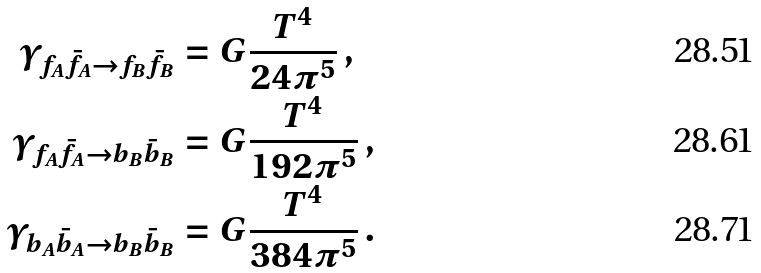Convert formula to latex. <formula><loc_0><loc_0><loc_500><loc_500>\gamma _ { f _ { A } \bar { f } _ { A } \to f _ { B } \bar { f } _ { B } } & = G \frac { T ^ { 4 } } { 2 4 \pi ^ { 5 } } \, , \\ \gamma _ { f _ { A } \bar { f } _ { A } \to b _ { B } \bar { b } _ { B } } & = G \frac { T ^ { 4 } } { 1 9 2 \pi ^ { 5 } } \, , \\ \gamma _ { b _ { A } \bar { b } _ { A } \to b _ { B } \bar { b } _ { B } } & = G \frac { T ^ { 4 } } { 3 8 4 \pi ^ { 5 } } \, .</formula> 